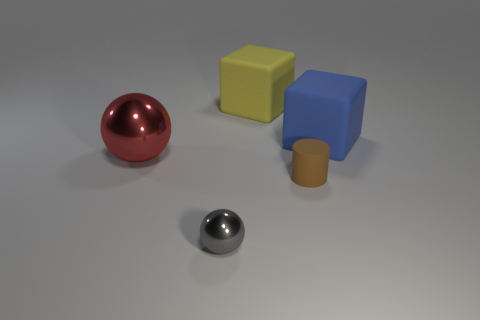What number of objects are big rubber objects that are behind the big blue matte object or large objects that are in front of the blue matte thing?
Make the answer very short. 2. How many other objects are the same color as the matte cylinder?
Provide a succinct answer. 0. There is a yellow rubber thing; is it the same shape as the large object that is right of the yellow matte block?
Your answer should be compact. Yes. Is the number of matte cylinders that are left of the big yellow rubber cube less than the number of blue rubber things that are behind the large blue block?
Offer a very short reply. No. What material is the other thing that is the same shape as the red object?
Give a very brief answer. Metal. There is a blue thing that is made of the same material as the yellow cube; what shape is it?
Your answer should be very brief. Cube. How many other gray things are the same shape as the small gray shiny thing?
Your answer should be very brief. 0. The object that is on the left side of the small gray shiny object left of the large yellow rubber object is what shape?
Provide a short and direct response. Sphere. Is the size of the rubber cylinder in front of the red sphere the same as the gray ball?
Your response must be concise. Yes. There is a object that is both on the left side of the large yellow object and right of the big sphere; how big is it?
Give a very brief answer. Small. 